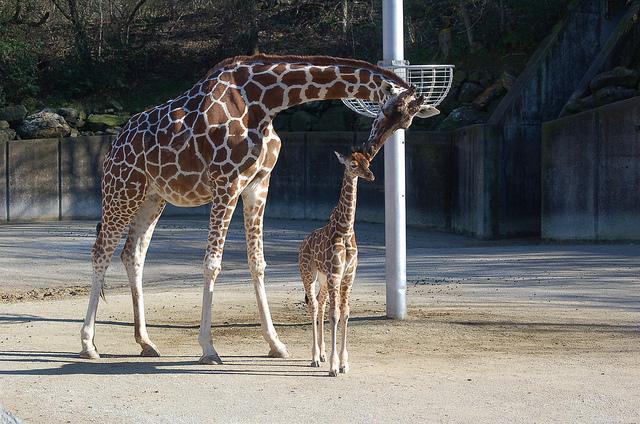How many legs are visible?
Give a very brief answer. 8. How many giraffes are in the photo?
Give a very brief answer. 2. How many birds are in the air flying?
Give a very brief answer. 0. 